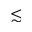<formula> <loc_0><loc_0><loc_500><loc_500>\lesssim</formula> 